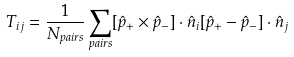<formula> <loc_0><loc_0><loc_500><loc_500>T _ { i j } = \frac { 1 } { N _ { p a i r s } } \sum _ { p a i r s } [ \hat { p } _ { + } \times \hat { p } _ { - } ] \cdot { \hat { n } _ { i } } [ \hat { p } _ { + } - \hat { p } _ { - } ] \cdot { \hat { n } _ { j } }</formula> 